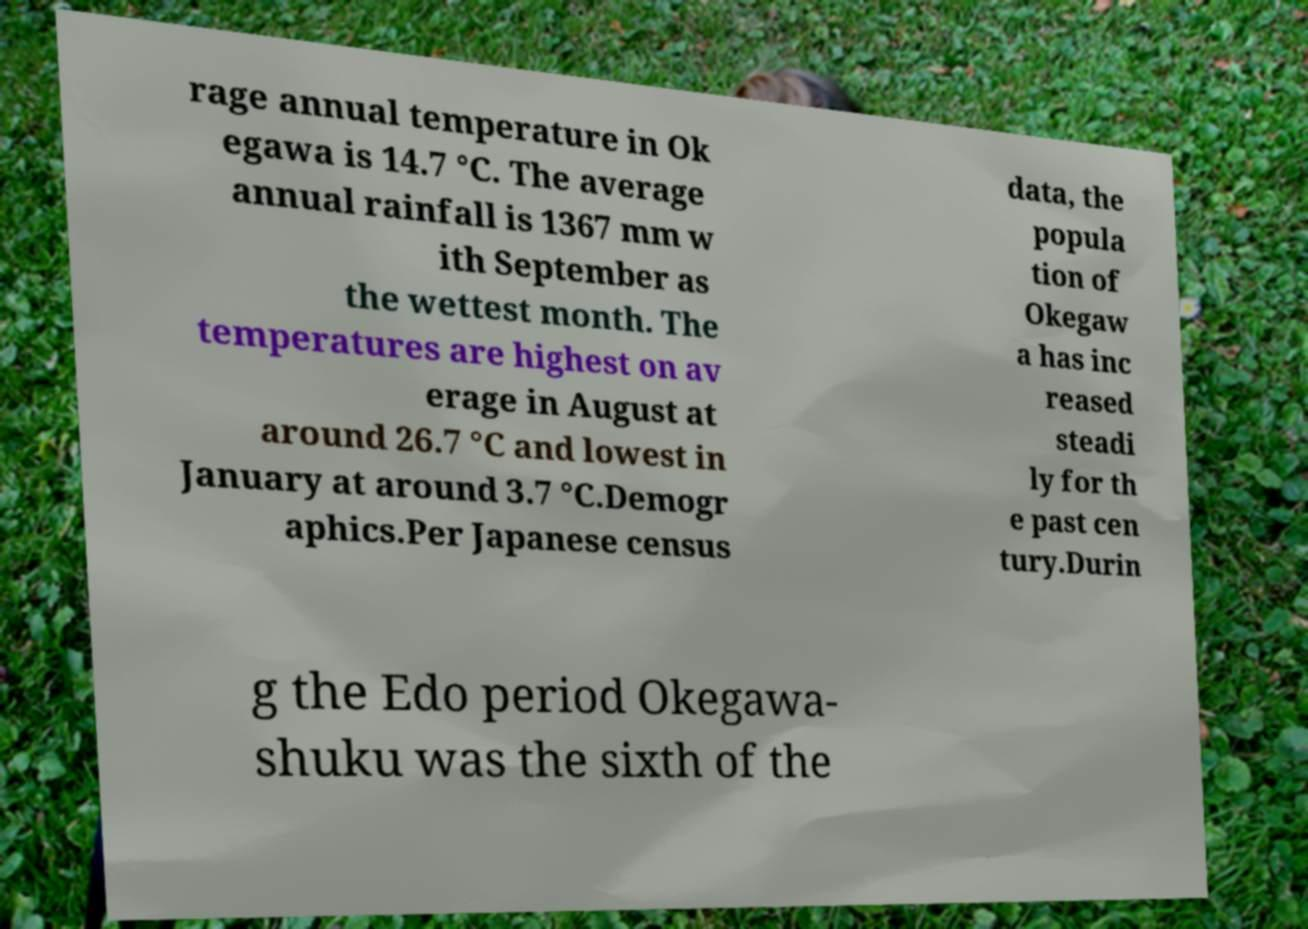Please identify and transcribe the text found in this image. rage annual temperature in Ok egawa is 14.7 °C. The average annual rainfall is 1367 mm w ith September as the wettest month. The temperatures are highest on av erage in August at around 26.7 °C and lowest in January at around 3.7 °C.Demogr aphics.Per Japanese census data, the popula tion of Okegaw a has inc reased steadi ly for th e past cen tury.Durin g the Edo period Okegawa- shuku was the sixth of the 